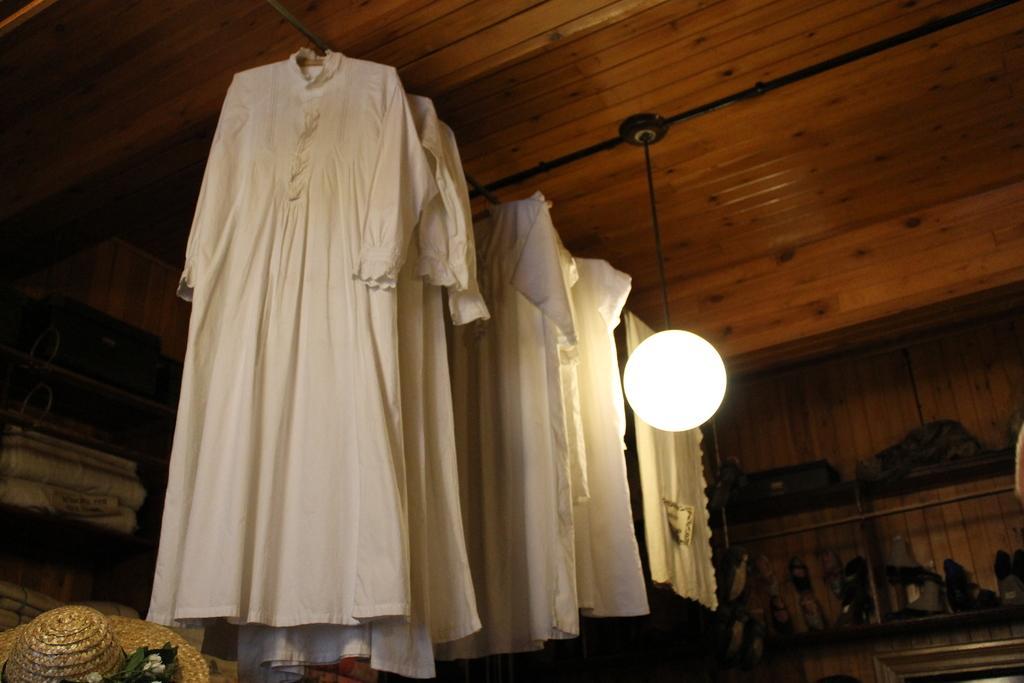Describe this image in one or two sentences. In the picture I can see clothes attached to the ceiling. I can also see light, a hat and some other objects. 